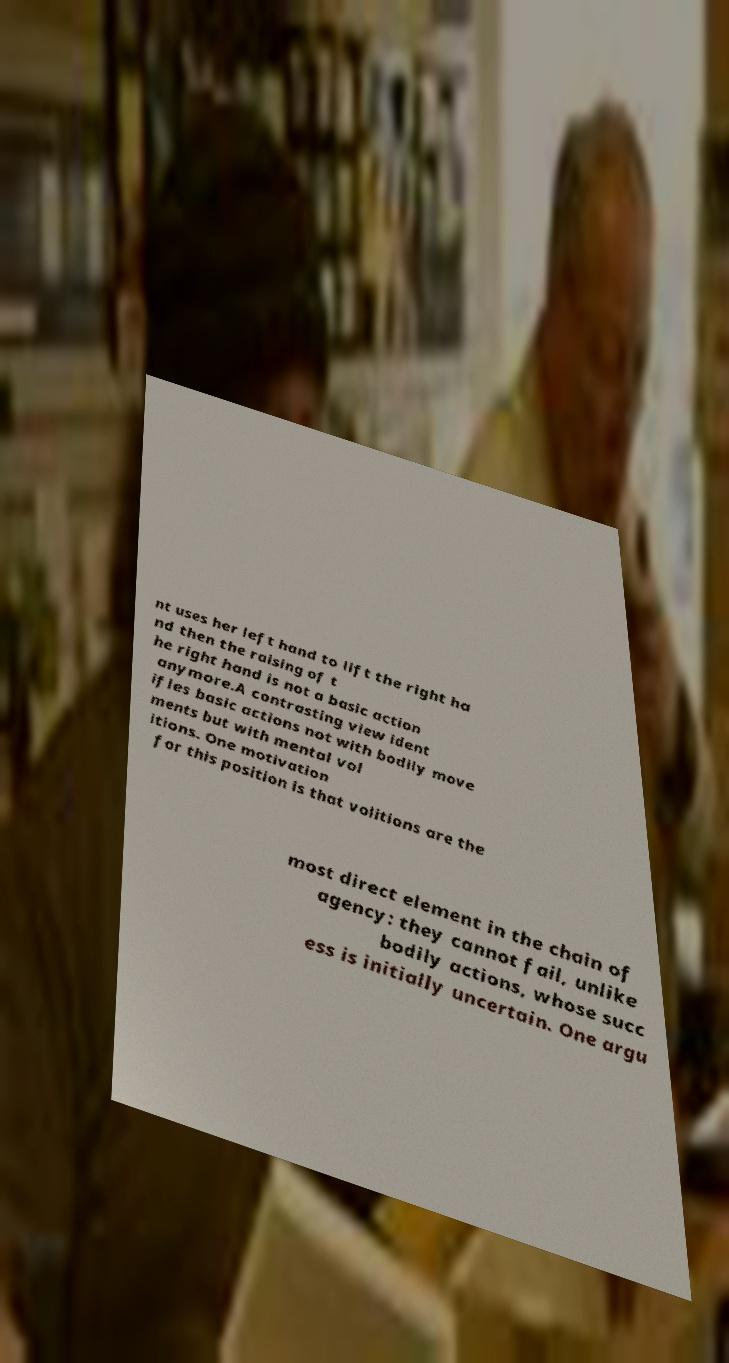Please read and relay the text visible in this image. What does it say? nt uses her left hand to lift the right ha nd then the raising of t he right hand is not a basic action anymore.A contrasting view ident ifies basic actions not with bodily move ments but with mental vol itions. One motivation for this position is that volitions are the most direct element in the chain of agency: they cannot fail, unlike bodily actions, whose succ ess is initially uncertain. One argu 